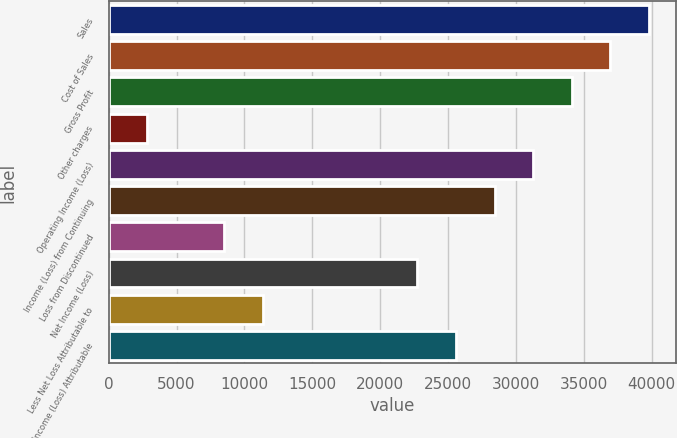Convert chart to OTSL. <chart><loc_0><loc_0><loc_500><loc_500><bar_chart><fcel>Sales<fcel>Cost of Sales<fcel>Gross Profit<fcel>Other charges<fcel>Operating Income (Loss)<fcel>Income (Loss) from Continuing<fcel>Loss from Discontinued<fcel>Net Income (Loss)<fcel>Less Net Loss Attributable to<fcel>Net Income (Loss) Attributable<nl><fcel>39801.8<fcel>36958.8<fcel>34115.9<fcel>2843.57<fcel>31273<fcel>28430<fcel>8529.45<fcel>22744.2<fcel>11372.4<fcel>25587.1<nl></chart> 